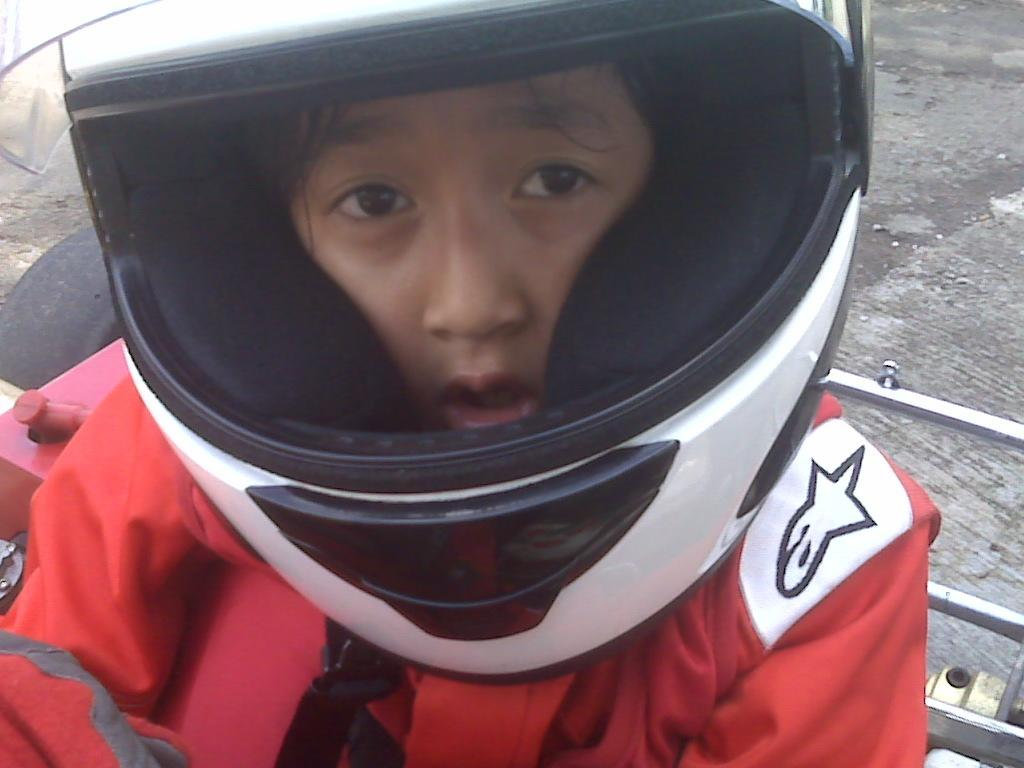Who is present in the image? There is a person in the image. What is the person wearing that stands out? The person is wearing an orange jacket. What type of protective gear is the person wearing? The person is wearing a helmet. What is the person sitting on in the image? The person is sitting on a vehicle. What can be seen in the distance behind the person? There is a road in the background of the image. How many sisters does the person in the image have? There is no information about the person's sisters in the image. What invention is the person using in the image? There is no specific invention mentioned or depicted in the image. 